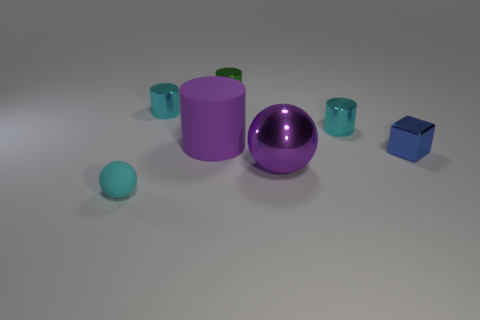Subtract all metal cylinders. How many cylinders are left? 1 Subtract all purple spheres. How many spheres are left? 1 Subtract 0 blue spheres. How many objects are left? 7 Subtract all cylinders. How many objects are left? 3 Subtract 1 balls. How many balls are left? 1 Subtract all gray spheres. Subtract all green cylinders. How many spheres are left? 2 Subtract all yellow cubes. How many green cylinders are left? 1 Subtract all small green objects. Subtract all large metal balls. How many objects are left? 5 Add 7 purple spheres. How many purple spheres are left? 8 Add 6 big gray matte spheres. How many big gray matte spheres exist? 6 